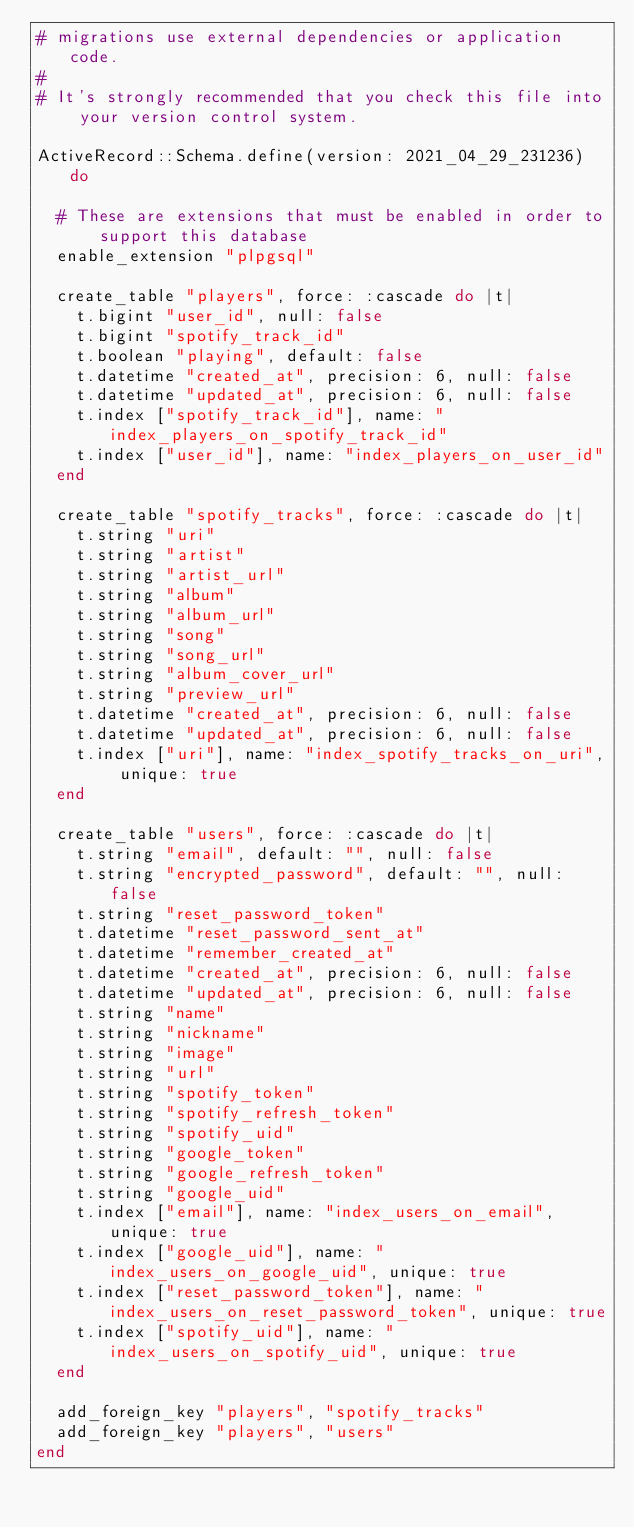<code> <loc_0><loc_0><loc_500><loc_500><_Ruby_># migrations use external dependencies or application code.
#
# It's strongly recommended that you check this file into your version control system.

ActiveRecord::Schema.define(version: 2021_04_29_231236) do

  # These are extensions that must be enabled in order to support this database
  enable_extension "plpgsql"

  create_table "players", force: :cascade do |t|
    t.bigint "user_id", null: false
    t.bigint "spotify_track_id"
    t.boolean "playing", default: false
    t.datetime "created_at", precision: 6, null: false
    t.datetime "updated_at", precision: 6, null: false
    t.index ["spotify_track_id"], name: "index_players_on_spotify_track_id"
    t.index ["user_id"], name: "index_players_on_user_id"
  end

  create_table "spotify_tracks", force: :cascade do |t|
    t.string "uri"
    t.string "artist"
    t.string "artist_url"
    t.string "album"
    t.string "album_url"
    t.string "song"
    t.string "song_url"
    t.string "album_cover_url"
    t.string "preview_url"
    t.datetime "created_at", precision: 6, null: false
    t.datetime "updated_at", precision: 6, null: false
    t.index ["uri"], name: "index_spotify_tracks_on_uri", unique: true
  end

  create_table "users", force: :cascade do |t|
    t.string "email", default: "", null: false
    t.string "encrypted_password", default: "", null: false
    t.string "reset_password_token"
    t.datetime "reset_password_sent_at"
    t.datetime "remember_created_at"
    t.datetime "created_at", precision: 6, null: false
    t.datetime "updated_at", precision: 6, null: false
    t.string "name"
    t.string "nickname"
    t.string "image"
    t.string "url"
    t.string "spotify_token"
    t.string "spotify_refresh_token"
    t.string "spotify_uid"
    t.string "google_token"
    t.string "google_refresh_token"
    t.string "google_uid"
    t.index ["email"], name: "index_users_on_email", unique: true
    t.index ["google_uid"], name: "index_users_on_google_uid", unique: true
    t.index ["reset_password_token"], name: "index_users_on_reset_password_token", unique: true
    t.index ["spotify_uid"], name: "index_users_on_spotify_uid", unique: true
  end

  add_foreign_key "players", "spotify_tracks"
  add_foreign_key "players", "users"
end
</code> 